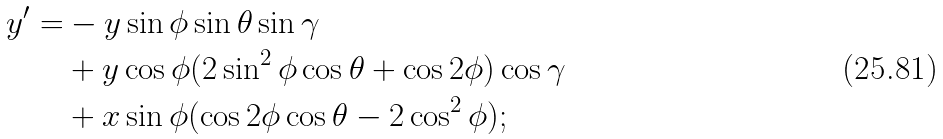<formula> <loc_0><loc_0><loc_500><loc_500>y ^ { \prime } = & - y \sin \phi \sin \theta \sin \gamma \\ & + y \cos \phi ( 2 \sin ^ { 2 } \phi \cos \theta + \cos 2 \phi ) \cos \gamma \\ & + x \sin \phi ( \cos 2 \phi \cos \theta - 2 \cos ^ { 2 } \phi ) ; \\</formula> 